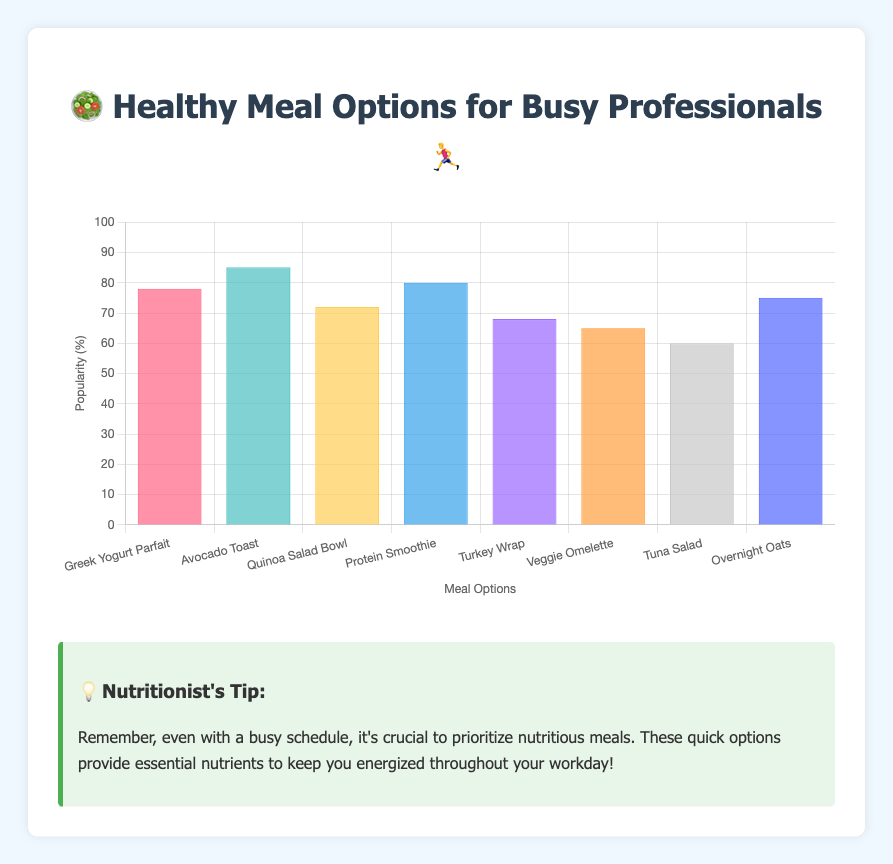what are the meal options listed on the chart? The meal options are labeled on the x-axis of the chart as "Greek Yogurt Parfait", "Avocado Toast", "Quinoa Salad Bowl", "Protein Smoothie", "Turkey Wrap", "Veggie Omelette", "Tuna Salad", and "Overnight Oats".
Answer: Greek Yogurt Parfait, Avocado Toast, Quinoa Salad Bowl, Protein Smoothie, Turkey Wrap, Veggie Omelette, Tuna Salad, Overnight Oats Which meal option has the highest popularity? To find the meal option with the highest popularity, look for the highest bar in the chart. "Avocado Toast" has the tallest bar representing a popularity of 85%.
Answer: Avocado Toast What is the average popularity of the meal options? First, sum the popularity percentages of all the meal options: 78 + 85 + 72 + 80 + 68 + 65 + 60 + 75 = 583. Then, divide by the number of meal options, which is 8. So, 583 / 8 = 72.875.
Answer: 72.875 Is the popularity of the Protein Smoothie greater than the Turkey Wrap? Compare the heights of the bars for "Protein Smoothie" and "Turkey Wrap". The "Protein Smoothie" has a popularity of 80% and the "Turkey Wrap" has 68%. Since 80% is greater than 68%, the Protein Smoothie is more popular.
Answer: Yes Which meal options have a popularity lower than 70%? Check all the bars with heights corresponding to popularity values less than 70%. "Turkey Wrap" (68%), "Veggie Omelette" (65%), and "Tuna Salad" (60%) are below 70%.
Answer: Turkey Wrap, Veggie Omelette, Tuna Salad How much more popular is Avocado Toast compared to Greek Yogurt Parfait? Subtract the popularity of "Greek Yogurt Parfait" from "Avocado Toast". 85 - 78 = 7.
Answer: 7% What is the nutritionist's tip mentioned at the bottom of the chart? The tip advises prioritizing nutritious meals even with a busy schedule to stay energized throughout the workday.
Answer: Prioritize nutritious meals to stay energized throughout the workday Which meal option has the closest popularity to 75%? Compare the popularity percentages to 75%. "Overnight Oats" has a popularity of 75%, which is closest.
Answer: Overnight Oats How many meal options have a popularity above the average of 72.875%? Calculate the average of 72.875% previously. The meal options above this average are "Greek Yogurt Parfait" (78%), "Avocado Toast" (85%), "Protein Smoothie" (80%), and "Overnight Oats" (75%).
Answer: 4 